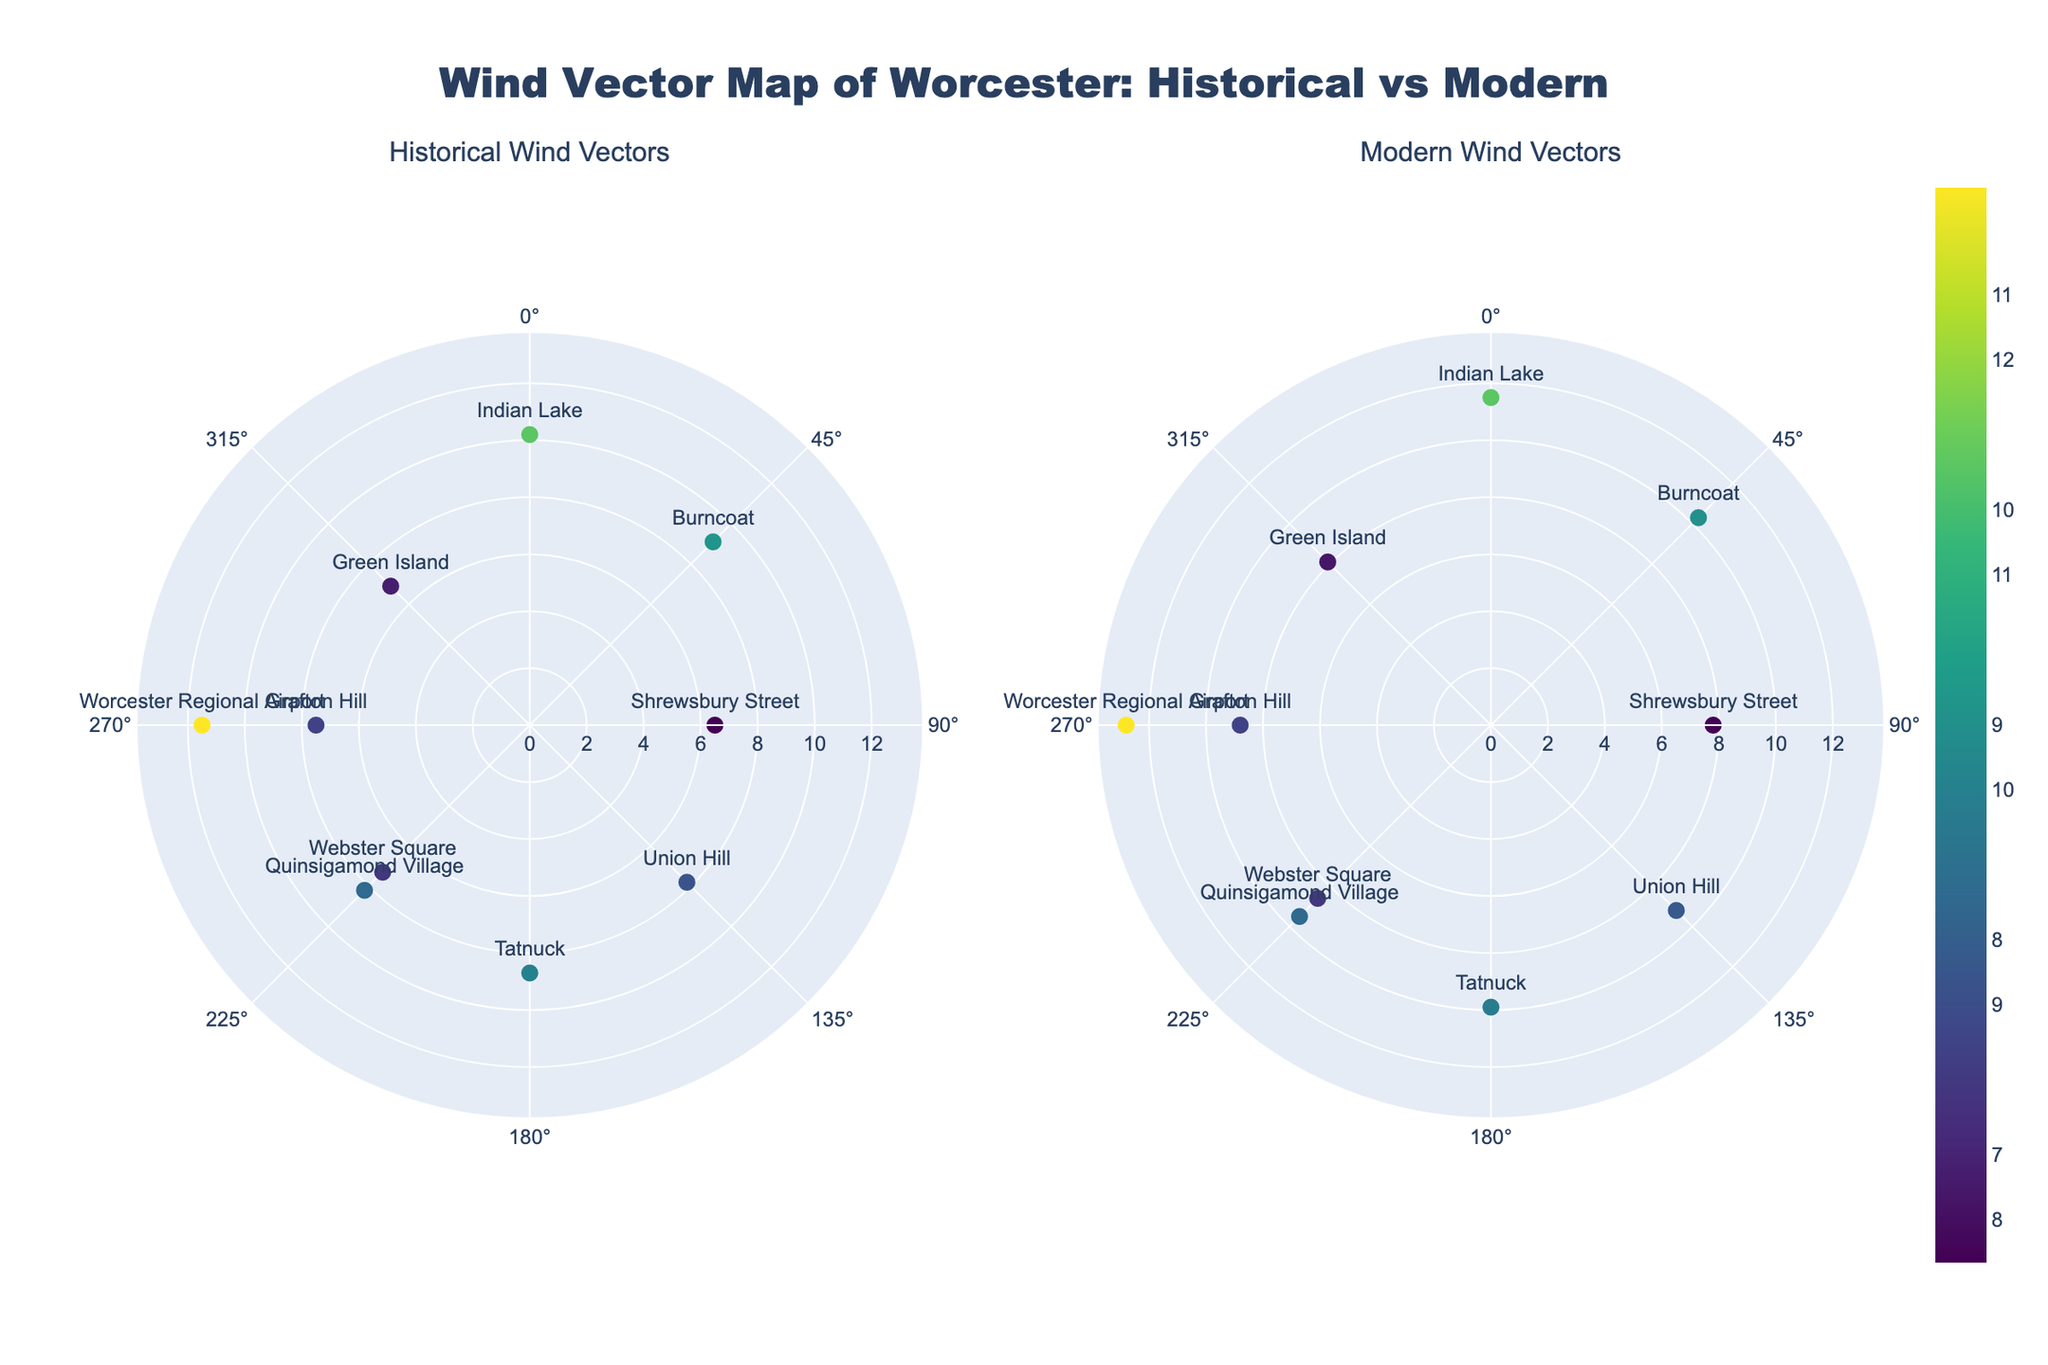What is the title of the figure? The title is found at the top of the figure, typically centered and in larger font. From the layout description, it is clear the title of the figure is: "Wind Vector Map of Worcester: Historical vs Modern".
Answer: Wind Vector Map of Worcester: Historical vs Modern How many locations are represented in the figure? By counting the data points provided in the data and represented in the figure, there are 10 unique locations displayed.
Answer: 10 Which location has the highest modern wind speed? By referencing the given data, Worcester Regional Airport has the highest modern wind speed of 12.8 mph. This would be visually represented by the longest radial distance in the modern wind vectors subplot.
Answer: Worcester Regional Airport At which direction are the vectors in the historical subplot oriented for Burncoat? Checking the given information, Burncoat's historical wind direction is NE, which corresponds to an angle of 45 degrees on the polar plot.
Answer: NE What is the difference in modern wind speed between the location with the highest speed and the location with the lowest speed? The highest modern wind speed is at Worcester Regional Airport (12.8 mph) and the lowest is at Shrewsbury Street (7.8 mph). The difference is calculated as 12.8 - 7.8.
Answer: 5 mph Which location shows the largest increase in wind speed from historical to modern data? By calculating the increase for each location using the given data: Quinsigamond Village (1.3), Grafton Hill (1.3), Green Island (1.2), Burncoat (1.2), Tatnuck (1.2), Union Hill (1.4), Shrewsbury Street (1.3), Indian Lake (1.3), Webster Square (1.3), Worcester Regional Airport (1.3), Union Hill shows the largest increase of 1.4 mph.
Answer: Union Hill Which two locations have the same historical and modern wind directions but different wind speeds in the historical data? By referencing the given data, both Quinsigamond Village and Webster Square have the same historical and modern direction (SW), but different wind speeds in the historical data (8.2 mph and 7.3 mph, respectively).
Answer: Quinsigamond Village and Webster Square Compare the overall trend of wind speed changes from historical to modern data across all locations. By comparing the given wind speed data for all locations, it is evident that the modern wind speeds are higher than the historical wind speeds at each location, indicating an overall increase in wind speed over time.
Answer: Increased wind speed 